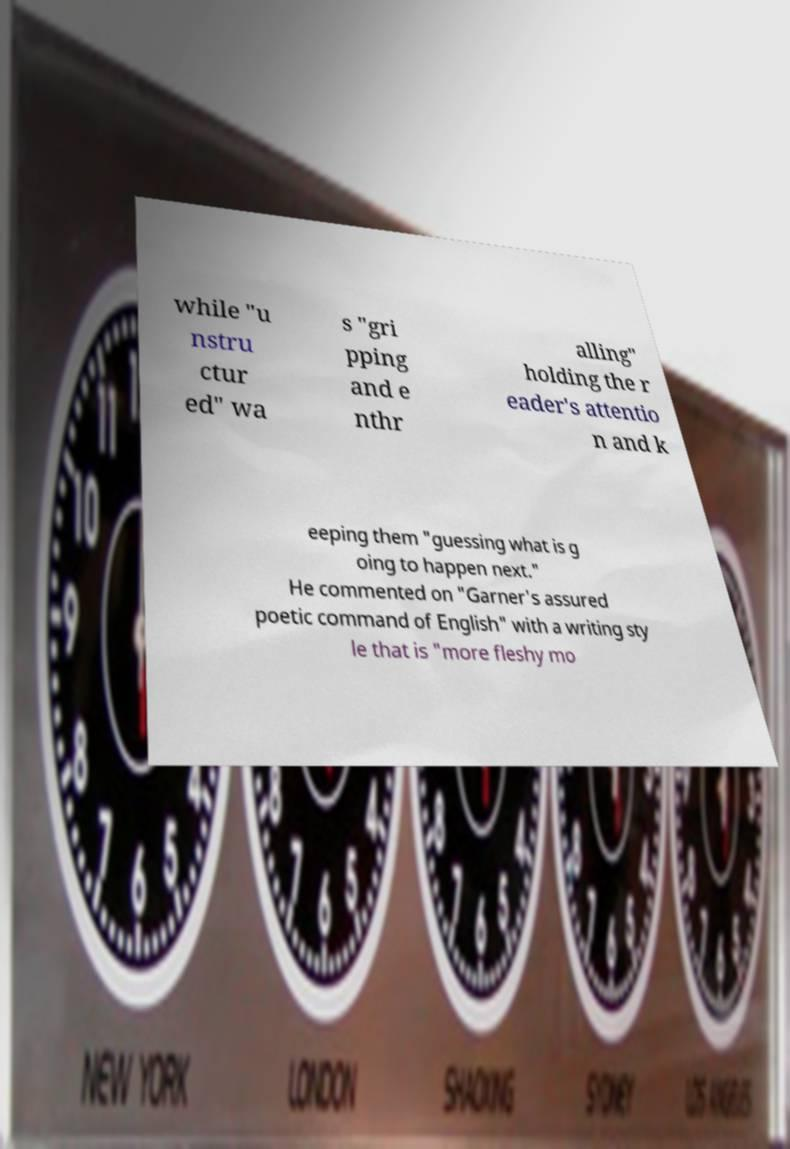Can you read and provide the text displayed in the image?This photo seems to have some interesting text. Can you extract and type it out for me? while "u nstru ctur ed" wa s "gri pping and e nthr alling" holding the r eader's attentio n and k eeping them "guessing what is g oing to happen next." He commented on "Garner's assured poetic command of English" with a writing sty le that is "more fleshy mo 